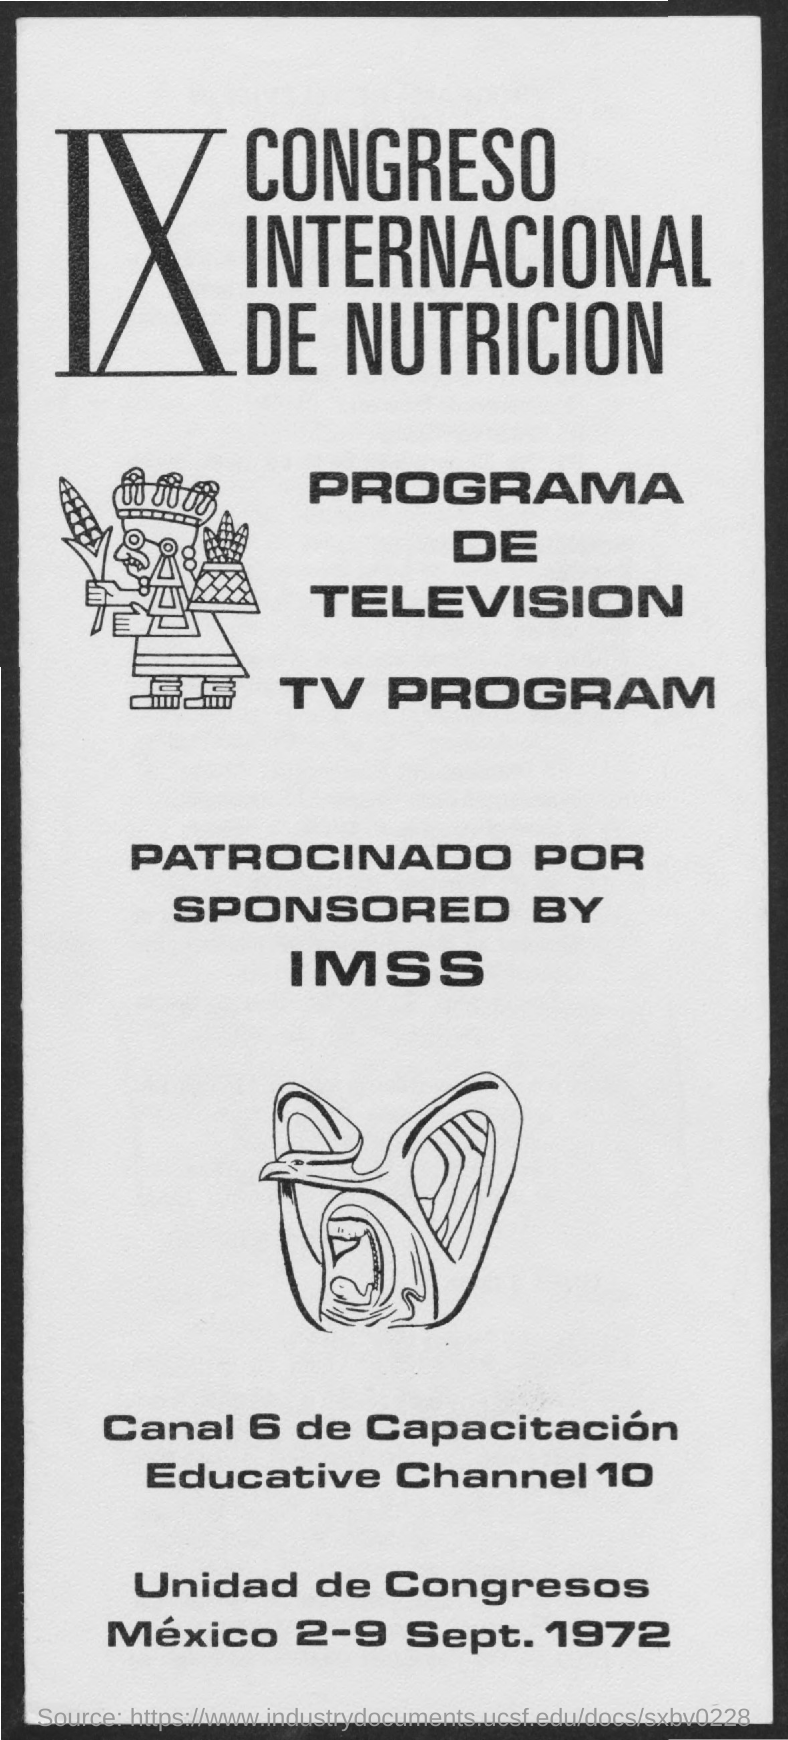What are the dates given at the bottom of the page?
Offer a terse response. 2-9 Sept. 1972. 